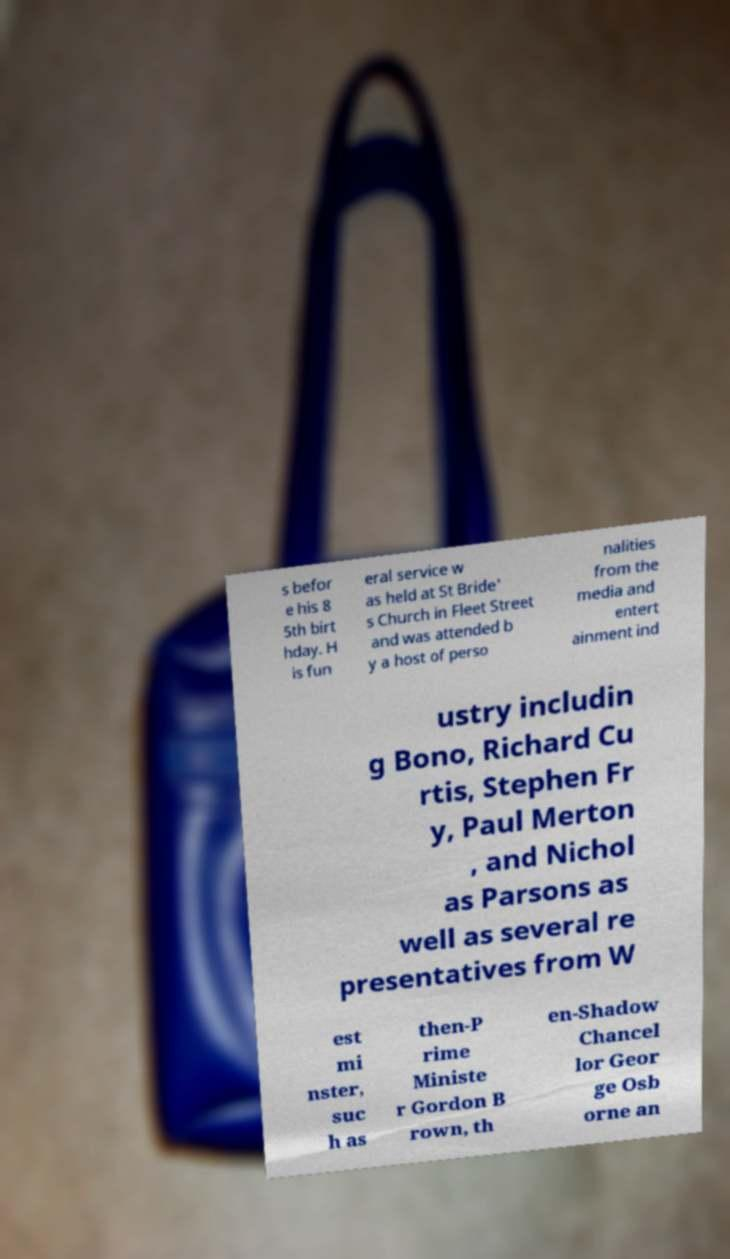Can you read and provide the text displayed in the image?This photo seems to have some interesting text. Can you extract and type it out for me? s befor e his 8 5th birt hday. H is fun eral service w as held at St Bride' s Church in Fleet Street and was attended b y a host of perso nalities from the media and entert ainment ind ustry includin g Bono, Richard Cu rtis, Stephen Fr y, Paul Merton , and Nichol as Parsons as well as several re presentatives from W est mi nster, suc h as then-P rime Ministe r Gordon B rown, th en-Shadow Chancel lor Geor ge Osb orne an 